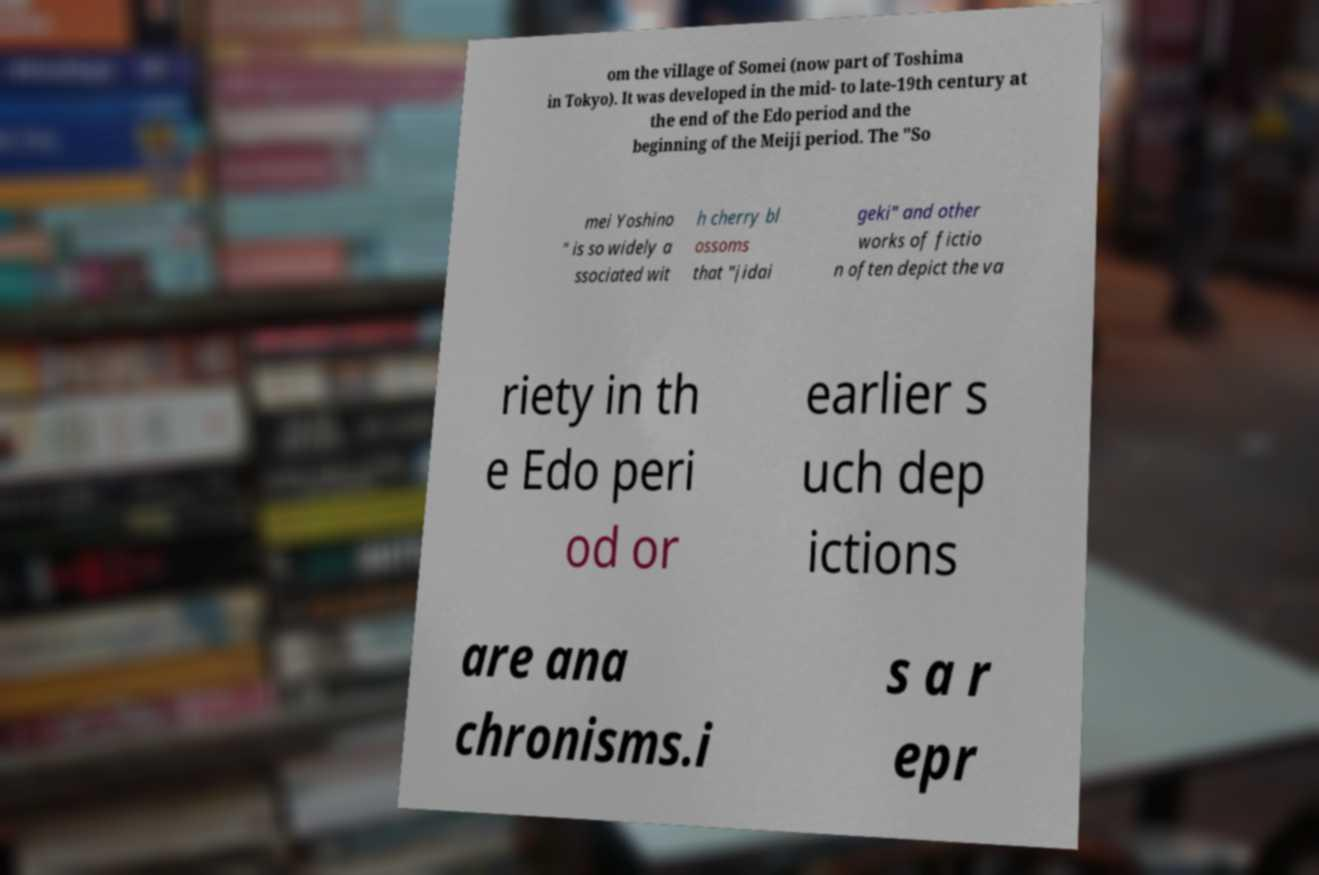Please identify and transcribe the text found in this image. om the village of Somei (now part of Toshima in Tokyo). It was developed in the mid- to late-19th century at the end of the Edo period and the beginning of the Meiji period. The "So mei Yoshino " is so widely a ssociated wit h cherry bl ossoms that "jidai geki" and other works of fictio n often depict the va riety in th e Edo peri od or earlier s uch dep ictions are ana chronisms.i s a r epr 